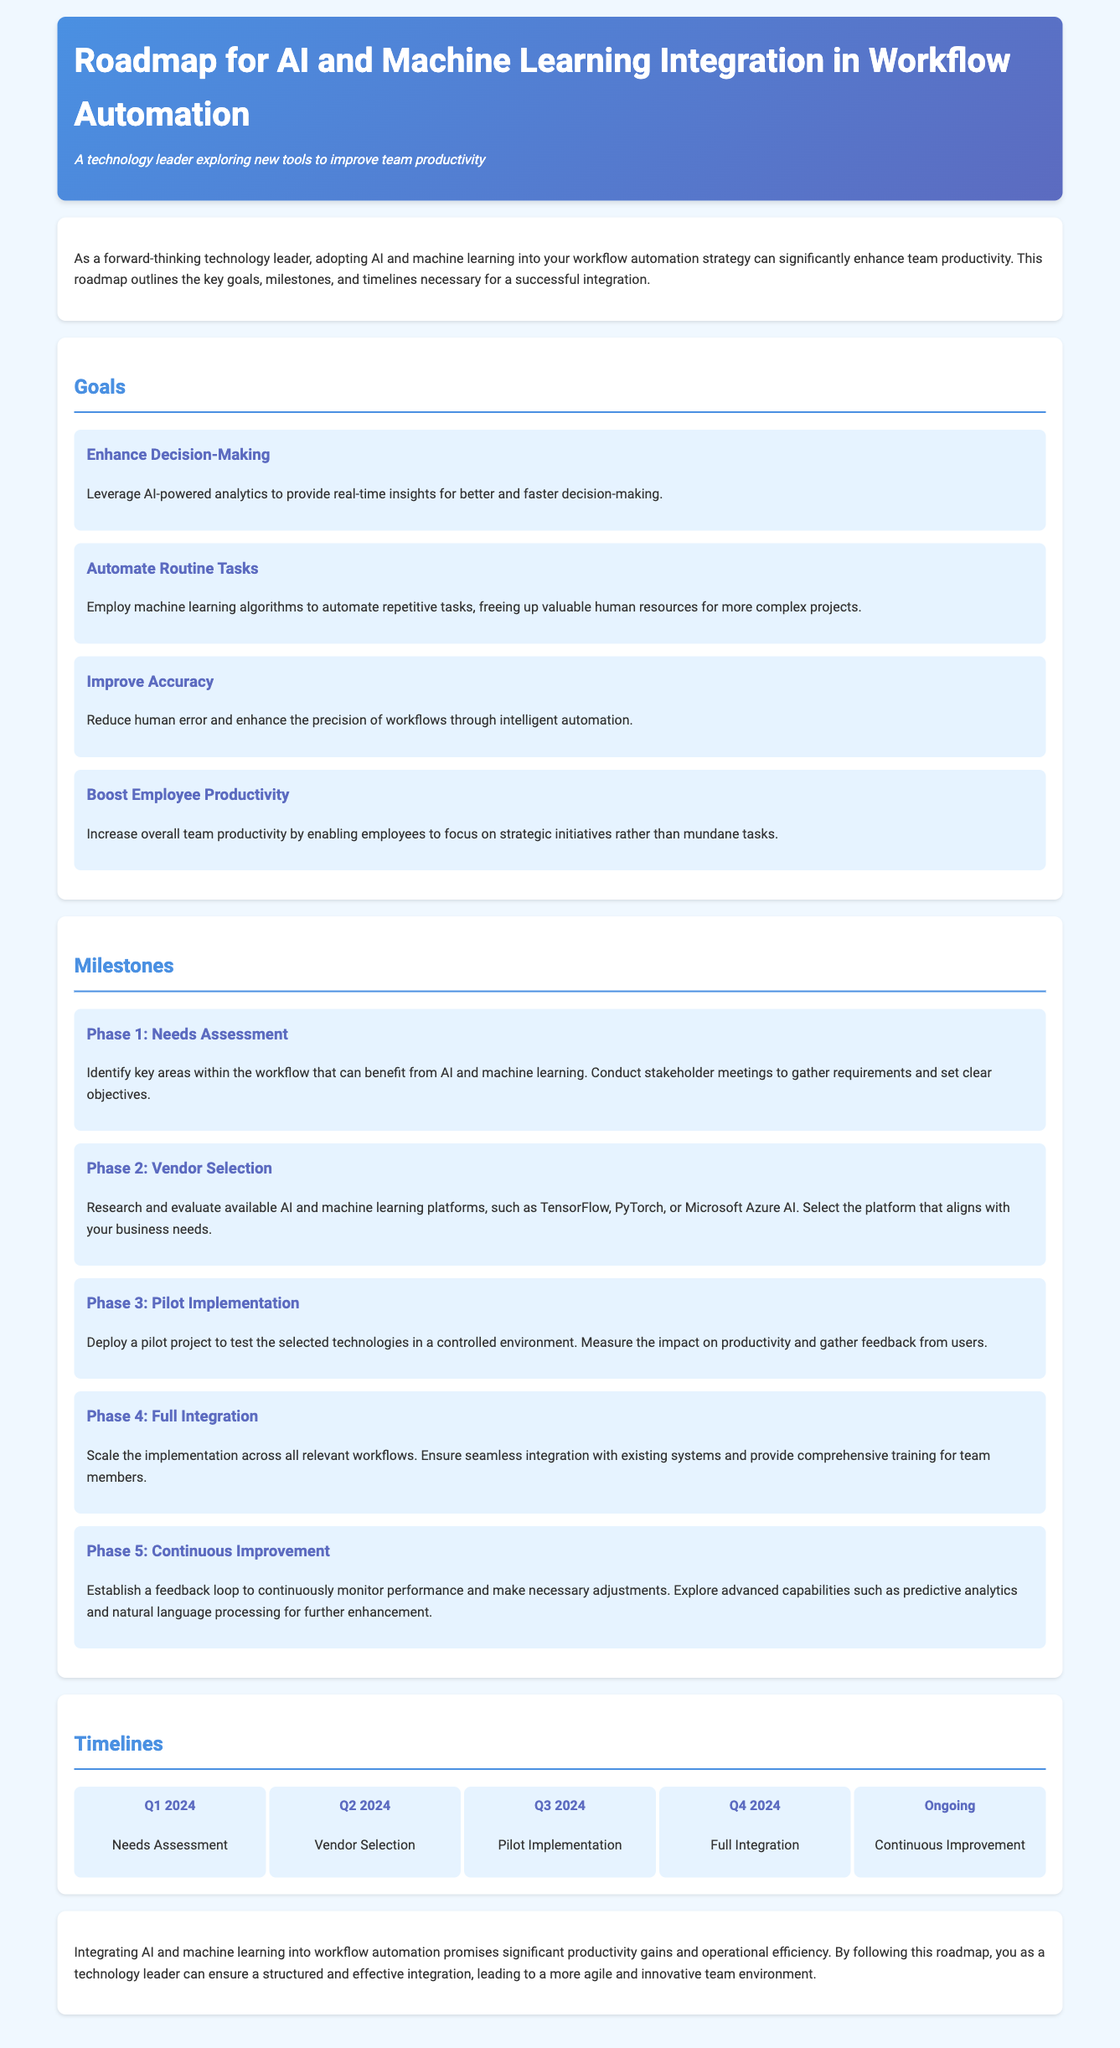what is the title of the document? The title is clearly stated in the header of the document.
Answer: Roadmap for AI and Machine Learning Integration in Workflow Automation what is the first goal mentioned in the document? The first goal appears under the Goals section and describes enhancing decision-making.
Answer: Enhance Decision-Making which phase involves testing technologies in a controlled environment? This phase is part of the Milestones section, specifically relating to deployment.
Answer: Pilot Implementation when does the Full Integration phase occur? The timeline is laid out in the Timelines section of the document, specifying the quarters of the year.
Answer: Q4 2024 what is the focus of Phase 5 in the Milestones? Phase 5 focuses on continuously monitoring performance and making necessary adjustments.
Answer: Continuous Improvement how many timeline items are listed in the document? The number of timeline items can be counted in the Timelines section.
Answer: 5 which quarter is dedicated to Vendor Selection? The quarter for Vendor Selection is clearly mentioned in the timeline layout.
Answer: Q2 2024 what is the purpose of the Needs Assessment phase? The purpose is stated in the description under the Milestones section.
Answer: Identify key areas within the workflow that can benefit from AI and machine learning which color theme is used in the document's design? The color theme is reflected in the overall design and background styles mentioned in the document.
Answer: Blue and White 